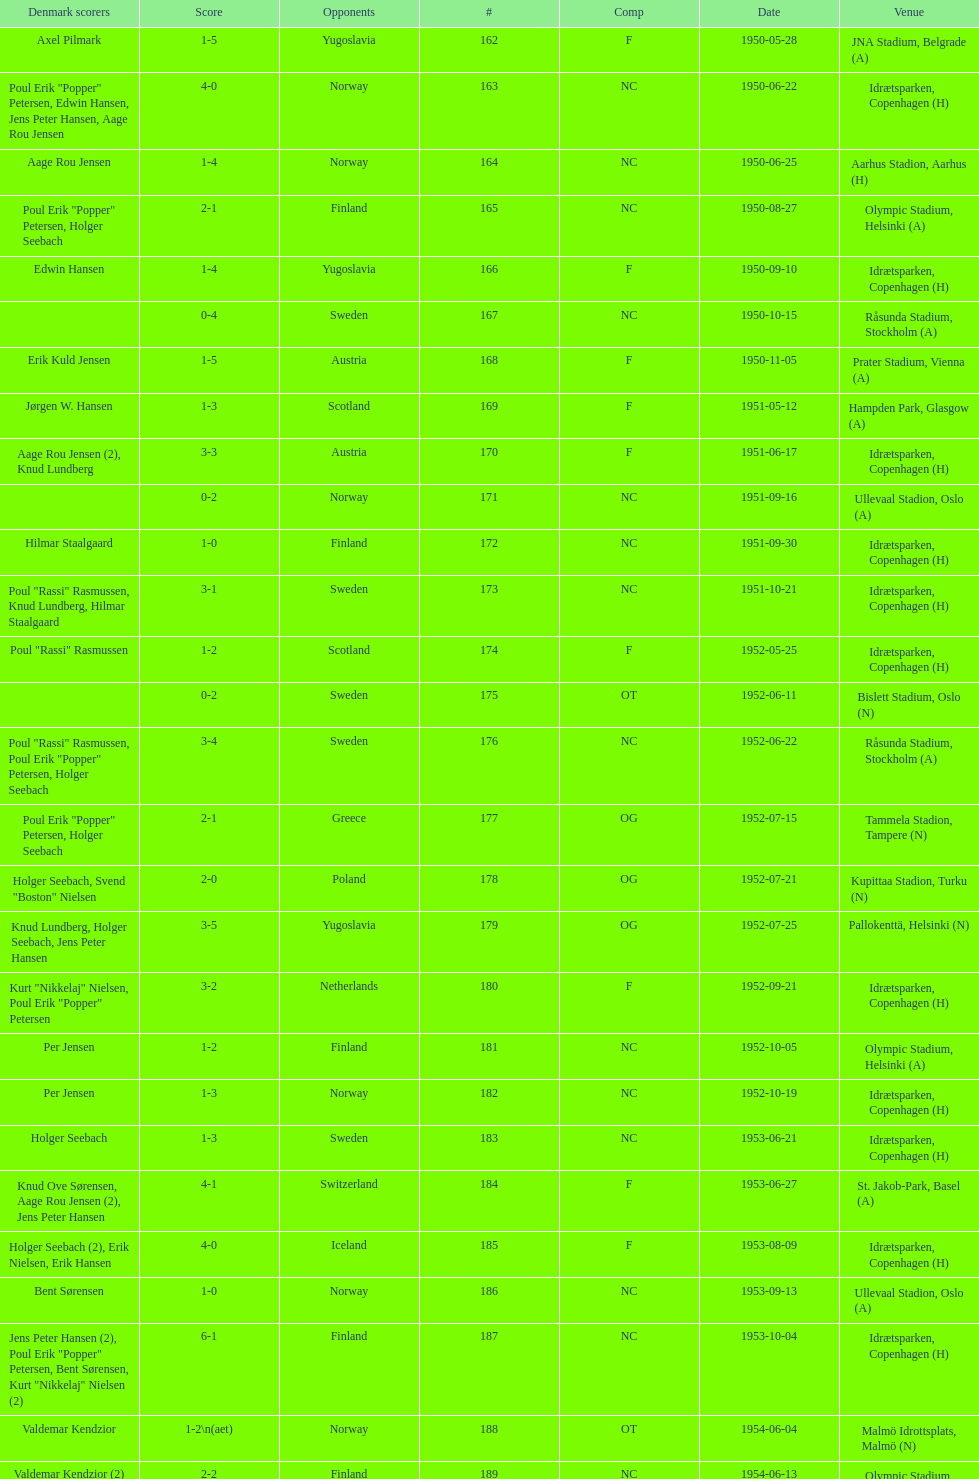What was the name of the venue mentioned prior to olympic stadium on august 27, 1950? Aarhus Stadion, Aarhus. Can you give me this table as a dict? {'header': ['Denmark scorers', 'Score', 'Opponents', '#', 'Comp', 'Date', 'Venue'], 'rows': [['Axel Pilmark', '1-5', 'Yugoslavia', '162', 'F', '1950-05-28', 'JNA Stadium, Belgrade (A)'], ['Poul Erik "Popper" Petersen, Edwin Hansen, Jens Peter Hansen, Aage Rou Jensen', '4-0', 'Norway', '163', 'NC', '1950-06-22', 'Idrætsparken, Copenhagen (H)'], ['Aage Rou Jensen', '1-4', 'Norway', '164', 'NC', '1950-06-25', 'Aarhus Stadion, Aarhus (H)'], ['Poul Erik "Popper" Petersen, Holger Seebach', '2-1', 'Finland', '165', 'NC', '1950-08-27', 'Olympic Stadium, Helsinki (A)'], ['Edwin Hansen', '1-4', 'Yugoslavia', '166', 'F', '1950-09-10', 'Idrætsparken, Copenhagen (H)'], ['', '0-4', 'Sweden', '167', 'NC', '1950-10-15', 'Råsunda Stadium, Stockholm (A)'], ['Erik Kuld Jensen', '1-5', 'Austria', '168', 'F', '1950-11-05', 'Prater Stadium, Vienna (A)'], ['Jørgen W. Hansen', '1-3', 'Scotland', '169', 'F', '1951-05-12', 'Hampden Park, Glasgow (A)'], ['Aage Rou Jensen (2), Knud Lundberg', '3-3', 'Austria', '170', 'F', '1951-06-17', 'Idrætsparken, Copenhagen (H)'], ['', '0-2', 'Norway', '171', 'NC', '1951-09-16', 'Ullevaal Stadion, Oslo (A)'], ['Hilmar Staalgaard', '1-0', 'Finland', '172', 'NC', '1951-09-30', 'Idrætsparken, Copenhagen (H)'], ['Poul "Rassi" Rasmussen, Knud Lundberg, Hilmar Staalgaard', '3-1', 'Sweden', '173', 'NC', '1951-10-21', 'Idrætsparken, Copenhagen (H)'], ['Poul "Rassi" Rasmussen', '1-2', 'Scotland', '174', 'F', '1952-05-25', 'Idrætsparken, Copenhagen (H)'], ['', '0-2', 'Sweden', '175', 'OT', '1952-06-11', 'Bislett Stadium, Oslo (N)'], ['Poul "Rassi" Rasmussen, Poul Erik "Popper" Petersen, Holger Seebach', '3-4', 'Sweden', '176', 'NC', '1952-06-22', 'Råsunda Stadium, Stockholm (A)'], ['Poul Erik "Popper" Petersen, Holger Seebach', '2-1', 'Greece', '177', 'OG', '1952-07-15', 'Tammela Stadion, Tampere (N)'], ['Holger Seebach, Svend "Boston" Nielsen', '2-0', 'Poland', '178', 'OG', '1952-07-21', 'Kupittaa Stadion, Turku (N)'], ['Knud Lundberg, Holger Seebach, Jens Peter Hansen', '3-5', 'Yugoslavia', '179', 'OG', '1952-07-25', 'Pallokenttä, Helsinki (N)'], ['Kurt "Nikkelaj" Nielsen, Poul Erik "Popper" Petersen', '3-2', 'Netherlands', '180', 'F', '1952-09-21', 'Idrætsparken, Copenhagen (H)'], ['Per Jensen', '1-2', 'Finland', '181', 'NC', '1952-10-05', 'Olympic Stadium, Helsinki (A)'], ['Per Jensen', '1-3', 'Norway', '182', 'NC', '1952-10-19', 'Idrætsparken, Copenhagen (H)'], ['Holger Seebach', '1-3', 'Sweden', '183', 'NC', '1953-06-21', 'Idrætsparken, Copenhagen (H)'], ['Knud Ove Sørensen, Aage Rou Jensen (2), Jens Peter Hansen', '4-1', 'Switzerland', '184', 'F', '1953-06-27', 'St. Jakob-Park, Basel (A)'], ['Holger Seebach (2), Erik Nielsen, Erik Hansen', '4-0', 'Iceland', '185', 'F', '1953-08-09', 'Idrætsparken, Copenhagen (H)'], ['Bent Sørensen', '1-0', 'Norway', '186', 'NC', '1953-09-13', 'Ullevaal Stadion, Oslo (A)'], ['Jens Peter Hansen (2), Poul Erik "Popper" Petersen, Bent Sørensen, Kurt "Nikkelaj" Nielsen (2)', '6-1', 'Finland', '187', 'NC', '1953-10-04', 'Idrætsparken, Copenhagen (H)'], ['Valdemar Kendzior', '1-2\\n(aet)', 'Norway', '188', 'OT', '1954-06-04', 'Malmö Idrottsplats, Malmö (N)'], ['Valdemar Kendzior (2)', '2-2', 'Finland', '189', 'NC', '1954-06-13', 'Olympic Stadium, Helsinki (A)'], ['Jørgen Olesen', '1-1', 'Switzerland', '190', 'F', '1954-09-19', 'Idrætsparken, Copenhagen (H)'], ['Jens Peter Hansen, Bent Sørensen', '2-5', 'Sweden', '191', 'NC', '1954-10-10', 'Råsunda Stadium, Stockholm (A)'], ['', '0-1', 'Norway', '192', 'NC', '1954-10-31', 'Idrætsparken, Copenhagen (H)'], ['Vagn Birkeland', '1-1', 'Netherlands', '193', 'F', '1955-03-13', 'Olympic Stadium, Amsterdam (A)'], ['', '0-6', 'Hungary', '194', 'F', '1955-05-15', 'Idrætsparken, Copenhagen (H)'], ['Jens Peter Hansen (2)', '2-1', 'Finland', '195', 'NC', '1955-06-19', 'Idrætsparken, Copenhagen (H)'], ['Aage Rou Jensen, Jens Peter Hansen, Poul Pedersen (2)', '4-0', 'Iceland', '196', 'F', '1955-06-03', 'Melavollur, Reykjavík (A)'], ['Jørgen Jacobsen', '1-1', 'Norway', '197', 'NC', '1955-09-11', 'Ullevaal Stadion, Oslo (A)'], ['Knud Lundberg', '1-5', 'England', '198', 'NC', '1955-10-02', 'Idrætsparken, Copenhagen (H)'], ['Ove Andersen (2), Knud Lundberg', '3-3', 'Sweden', '199', 'NC', '1955-10-16', 'Idrætsparken, Copenhagen (H)'], ['Knud Lundberg', '1-5', 'USSR', '200', 'F', '1956-05-23', 'Dynamo Stadium, Moscow (A)'], ['Knud Lundberg, Poul Pedersen', '2-3', 'Norway', '201', 'NC', '1956-06-24', 'Idrætsparken, Copenhagen (H)'], ['Ove Andersen, Aage Rou Jensen', '2-5', 'USSR', '202', 'F', '1956-07-01', 'Idrætsparken, Copenhagen (H)'], ['Poul Pedersen, Jørgen Hansen, Ove Andersen (2)', '4-0', 'Finland', '203', 'NC', '1956-09-16', 'Olympic Stadium, Helsinki (A)'], ['Aage Rou Jensen', '1-2', 'Republic of Ireland', '204', 'WCQ', '1956-10-03', 'Dalymount Park, Dublin (A)'], ['Jens Peter Hansen', '1-1', 'Sweden', '205', 'NC', '1956-10-21', 'Råsunda Stadium, Stockholm (A)'], ['Jørgen Olesen, Knud Lundberg', '2-2', 'Netherlands', '206', 'F', '1956-11-04', 'Idrætsparken, Copenhagen (H)'], ['Ove Bech Nielsen (2)', '2-5', 'England', '207', 'WCQ', '1956-12-05', 'Molineux, Wolverhampton (A)'], ['John Jensen', '1-4', 'England', '208', 'WCQ', '1957-05-15', 'Idrætsparken, Copenhagen (H)'], ['Aage Rou Jensen', '1-1', 'Bulgaria', '209', 'F', '1957-05-26', 'Idrætsparken, Copenhagen (H)'], ['', '0-2', 'Finland', '210', 'OT', '1957-06-18', 'Olympic Stadium, Helsinki (A)'], ['Egon Jensen, Jørgen Hansen', '2-0', 'Norway', '211', 'OT', '1957-06-19', 'Tammela Stadion, Tampere (N)'], ['Jens Peter Hansen', '1-2', 'Sweden', '212', 'NC', '1957-06-30', 'Idrætsparken, Copenhagen (H)'], ['Egon Jensen (3), Poul Pedersen, Jens Peter Hansen (2)', '6-2', 'Iceland', '213', 'OT', '1957-07-10', 'Laugardalsvöllur, Reykjavík (A)'], ['Poul Pedersen, Peder Kjær', '2-2', 'Norway', '214', 'NC', '1957-09-22', 'Ullevaal Stadion, Oslo (A)'], ['', '0-2', 'Republic of Ireland', '215', 'WCQ', '1957-10-02', 'Idrætsparken, Copenhagen (H)'], ['Finn Alfred Hansen, Ove Bech Nielsen, Mogens Machon', '3-0', 'Finland', '216', 'NC', '1957-10-13', 'Idrætsparken, Copenhagen (H)'], ['Poul Pedersen, Henning Enoksen (2)', '3-2', 'Curaçao', '217', 'F', '1958-05-15', 'Aarhus Stadion, Aarhus (H)'], ['Jørn Sørensen, Poul Pedersen (2)', '3-2', 'Poland', '218', 'F', '1958-05-25', 'Idrætsparken, Copenhagen (H)'], ['Poul Pedersen', '1-2', 'Norway', '219', 'NC', '1958-06-29', 'Idrætsparken, Copenhagen (H)'], ['Poul Pedersen, Mogens Machon, John Danielsen (2)', '4-1', 'Finland', '220', 'NC', '1958-09-14', 'Olympic Stadium, Helsinki (A)'], ['Henning Enoksen', '1-1', 'West Germany', '221', 'F', '1958-09-24', 'Idrætsparken, Copenhagen (H)'], ['Henning Enoksen', '1-5', 'Netherlands', '222', 'F', '1958-10-15', 'Idrætsparken, Copenhagen (H)'], ['Ole Madsen (2), Henning Enoksen, Jørn Sørensen', '4-4', 'Sweden', '223', 'NC', '1958-10-26', 'Råsunda Stadium, Stockholm (A)'], ['', '0-6', 'Sweden', '224', 'NC', '1959-06-21', 'Idrætsparken, Copenhagen (H)'], ['Jens Peter Hansen (2), Ole Madsen (2)', '4-2', 'Iceland', '225', 'OGQ', '1959-06-26', 'Laugardalsvöllur, Reykjavík (A)'], ['Henning Enoksen, Ole Madsen', '2-1', 'Norway', '226', 'OGQ', '1959-07-02', 'Idrætsparken, Copenhagen (H)'], ['Henning Enoksen', '1-1', 'Iceland', '227', 'OGQ', '1959-08-18', 'Idrætsparken, Copenhagen (H)'], ['Harald Nielsen, Henning Enoksen (2), Poul Pedersen', '4-2', 'Norway', '228', 'OGQ\\nNC', '1959-09-13', 'Ullevaal Stadion, Oslo (A)'], ['Poul Pedersen, Bent Hansen', '2-2', 'Czechoslovakia', '229', 'ENQ', '1959-09-23', 'Idrætsparken, Copenhagen (H)'], ['Harald Nielsen (3), John Kramer', '4-0', 'Finland', '230', 'NC', '1959-10-04', 'Idrætsparken, Copenhagen (H)'], ['John Kramer', '1-5', 'Czechoslovakia', '231', 'ENQ', '1959-10-18', 'Stadion Za Lužánkami, Brno (A)'], ['Henning Enoksen (2), Poul Pedersen', '3-1', 'Greece', '232', 'F', '1959-12-02', 'Olympic Stadium, Athens (A)'], ['Henning Enoksen', '1-2', 'Bulgaria', '233', 'F', '1959-12-06', 'Vasil Levski National Stadium, Sofia (A)']]} 